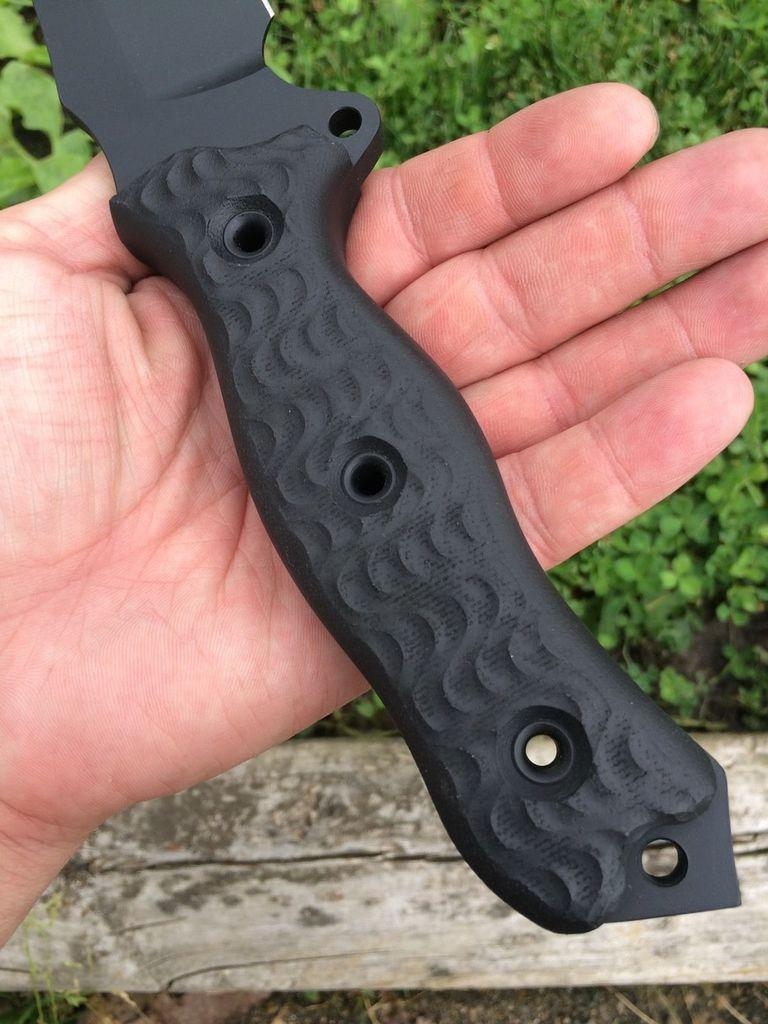What object is being held by someone in the image? There is a knife in the image, and it is being held by someone. What can be seen in the background of the image? There are plants and a wooden log in the background of the image. What type of discovery was made by the judge using the knife in the image? There is no judge or discovery present in the image; it only features a knife being held by someone and plants and a wooden log in the background. 